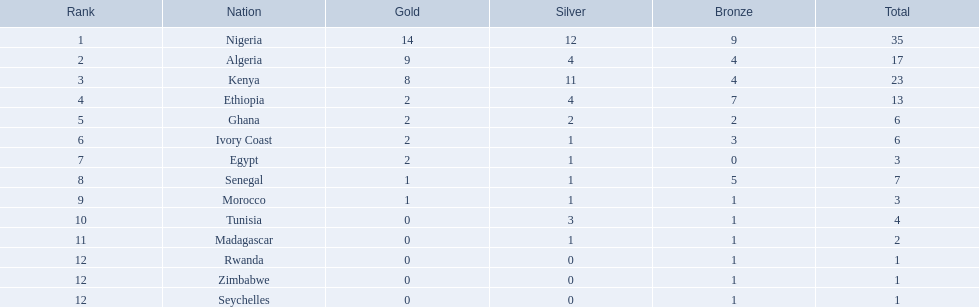Which nations competed in the 1989 african championships in athletics? Nigeria, Algeria, Kenya, Ethiopia, Ghana, Ivory Coast, Egypt, Senegal, Morocco, Tunisia, Madagascar, Rwanda, Zimbabwe, Seychelles. Of these nations, which earned 0 bronze medals? Egypt. Would you mind parsing the complete table? {'header': ['Rank', 'Nation', 'Gold', 'Silver', 'Bronze', 'Total'], 'rows': [['1', 'Nigeria', '14', '12', '9', '35'], ['2', 'Algeria', '9', '4', '4', '17'], ['3', 'Kenya', '8', '11', '4', '23'], ['4', 'Ethiopia', '2', '4', '7', '13'], ['5', 'Ghana', '2', '2', '2', '6'], ['6', 'Ivory Coast', '2', '1', '3', '6'], ['7', 'Egypt', '2', '1', '0', '3'], ['8', 'Senegal', '1', '1', '5', '7'], ['9', 'Morocco', '1', '1', '1', '3'], ['10', 'Tunisia', '0', '3', '1', '4'], ['11', 'Madagascar', '0', '1', '1', '2'], ['12', 'Rwanda', '0', '0', '1', '1'], ['12', 'Zimbabwe', '0', '0', '1', '1'], ['12', 'Seychelles', '0', '0', '1', '1']]} In the 1989 african championships in athletics, which countries were involved? Nigeria, Algeria, Kenya, Ethiopia, Ghana, Ivory Coast, Egypt, Senegal, Morocco, Tunisia, Madagascar, Rwanda, Zimbabwe, Seychelles. Which ones won bronze medals? Nigeria, Algeria, Kenya, Ethiopia, Ghana, Ivory Coast, Senegal, Morocco, Tunisia, Madagascar, Rwanda, Zimbabwe, Seychelles. Which country did not win a bronze medal? Egypt. 